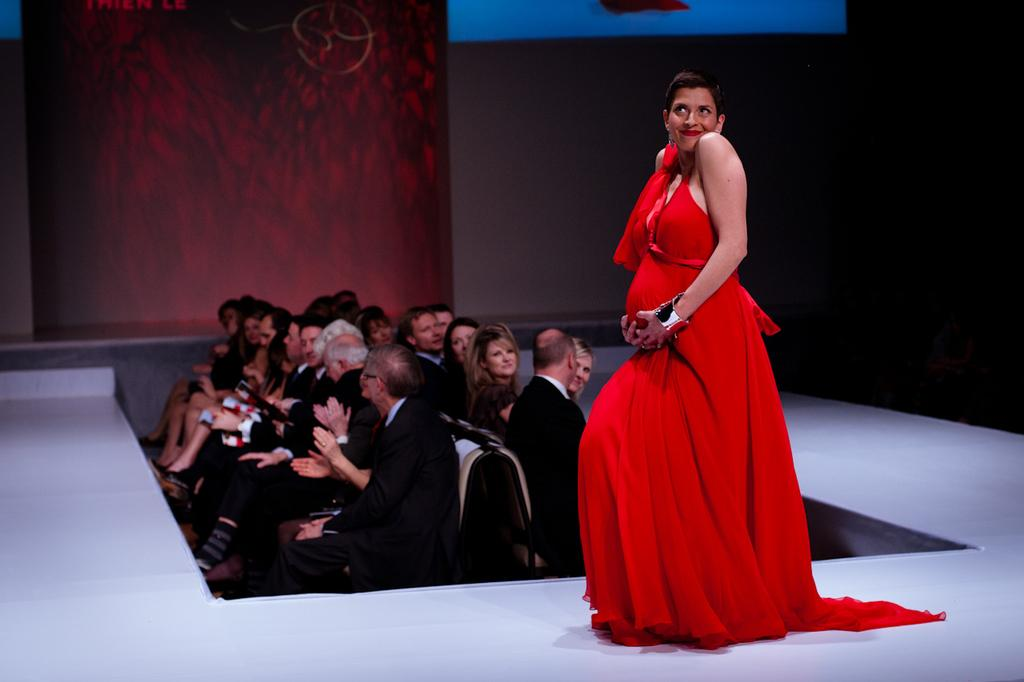What are the people in the image doing? The people in the image are sitting on chairs. Can you describe the position of the woman in the image? There is a woman standing on the floor in the image. What type of feather can be seen on the school's wall in the image? There is no mention of a school or a feather in the image; it only features people sitting on chairs and a woman standing on the floor. 